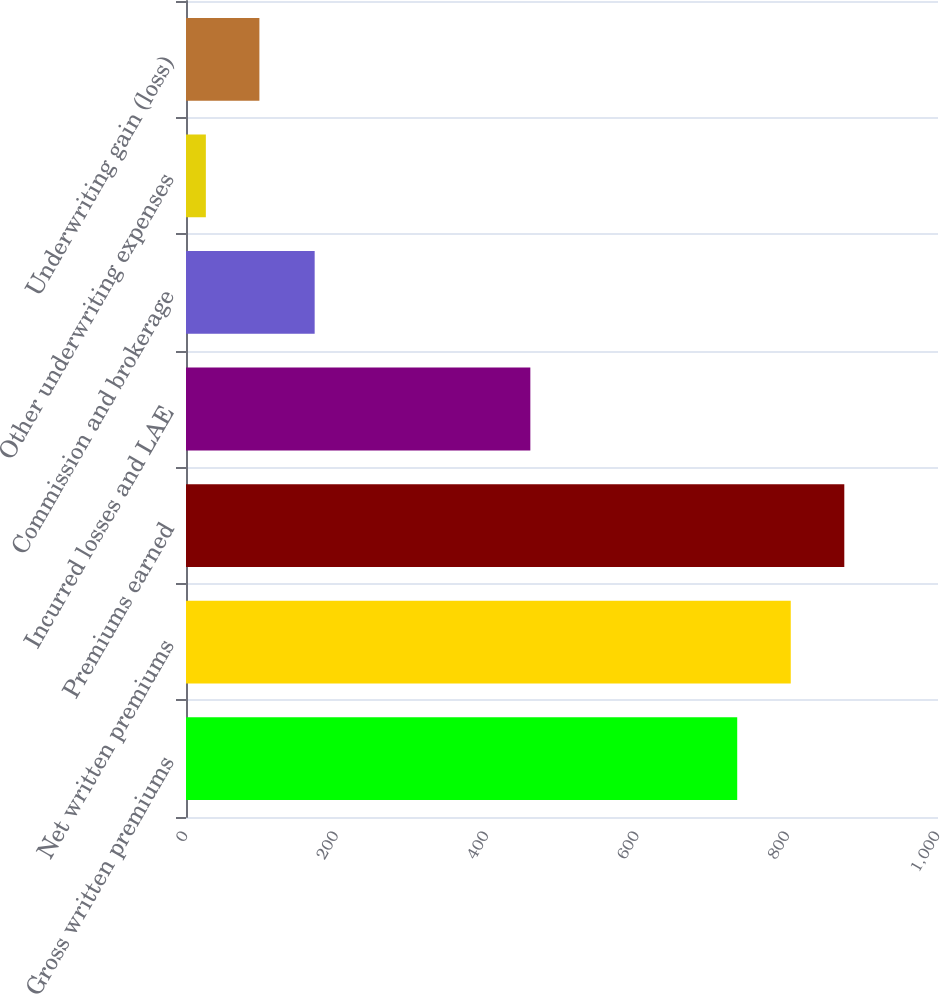Convert chart to OTSL. <chart><loc_0><loc_0><loc_500><loc_500><bar_chart><fcel>Gross written premiums<fcel>Net written premiums<fcel>Premiums earned<fcel>Incurred losses and LAE<fcel>Commission and brokerage<fcel>Other underwriting expenses<fcel>Underwriting gain (loss)<nl><fcel>733<fcel>804.2<fcel>875.4<fcel>457.9<fcel>171.1<fcel>26.4<fcel>97.6<nl></chart> 